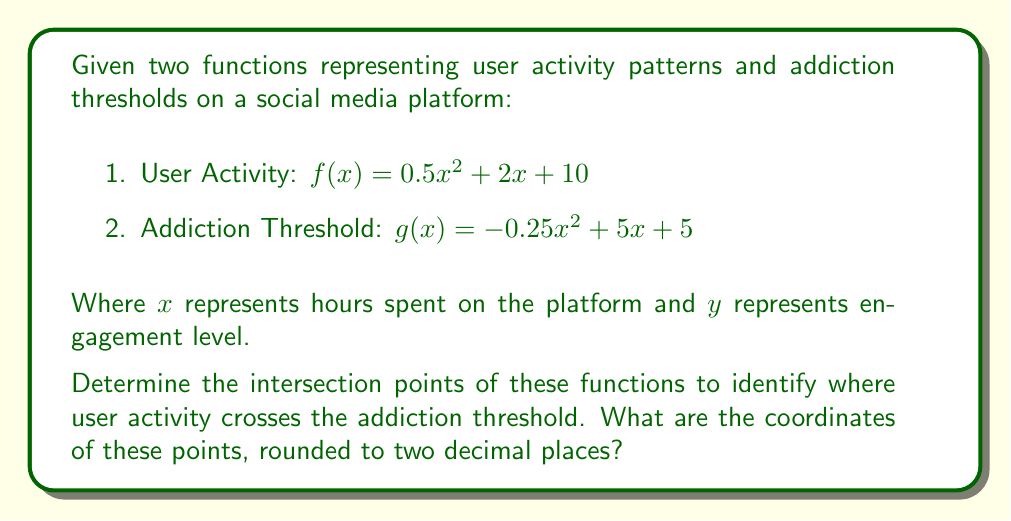Help me with this question. To find the intersection points, we need to solve the equation $f(x) = g(x)$:

1) Set up the equation:
   $0.5x^2 + 2x + 10 = -0.25x^2 + 5x + 5$

2) Rearrange to standard form:
   $0.5x^2 + 2x + 10 + 0.25x^2 - 5x - 5 = 0$
   $0.75x^2 - 3x + 5 = 0$

3) Multiply all terms by 4 to eliminate fractions:
   $3x^2 - 12x + 20 = 0$

4) Use the quadratic formula: $x = \frac{-b \pm \sqrt{b^2 - 4ac}}{2a}$
   Where $a = 3$, $b = -12$, and $c = 20$

5) Substitute into the formula:
   $x = \frac{12 \pm \sqrt{(-12)^2 - 4(3)(20)}}{2(3)}$
   $x = \frac{12 \pm \sqrt{144 - 240}}{6}$
   $x = \frac{12 \pm \sqrt{-96}}{6}$
   $x = \frac{12 \pm 4\sqrt{6}i}{6}$
   $x = 2 \pm \frac{2\sqrt{6}i}{3}$

6) The real solutions are:
   $x_1 = 2 + \frac{2\sqrt{6}}{3} \approx 3.63$
   $x_2 = 2 - \frac{2\sqrt{6}}{3} \approx 0.37$

7) Calculate the corresponding y-values:
   For $x_1 = 3.63$:
   $y_1 = 0.5(3.63)^2 + 2(3.63) + 10 \approx 23.17$

   For $x_2 = 0.37$:
   $y_2 = 0.5(0.37)^2 + 2(0.37) + 10 \approx 11.07$

Therefore, the intersection points are approximately (3.63, 23.17) and (0.37, 11.07).
Answer: (3.63, 23.17) and (0.37, 11.07) 